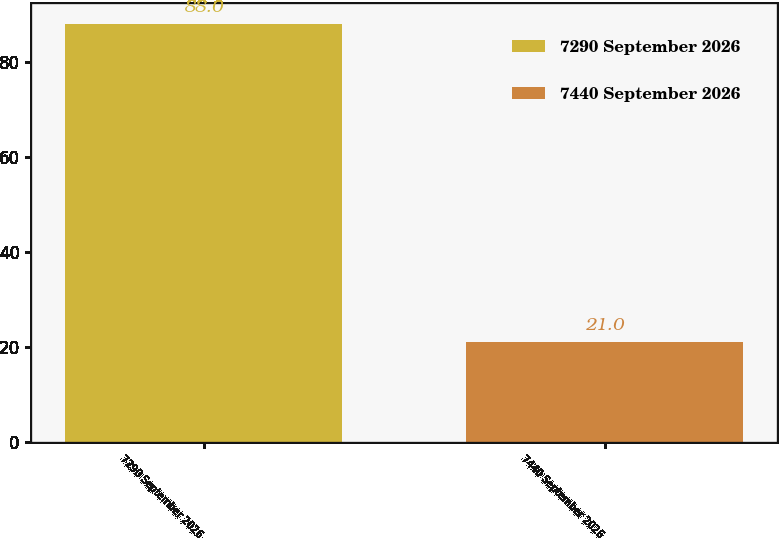Convert chart. <chart><loc_0><loc_0><loc_500><loc_500><bar_chart><fcel>7290 September 2026<fcel>7440 September 2026<nl><fcel>88<fcel>21<nl></chart> 